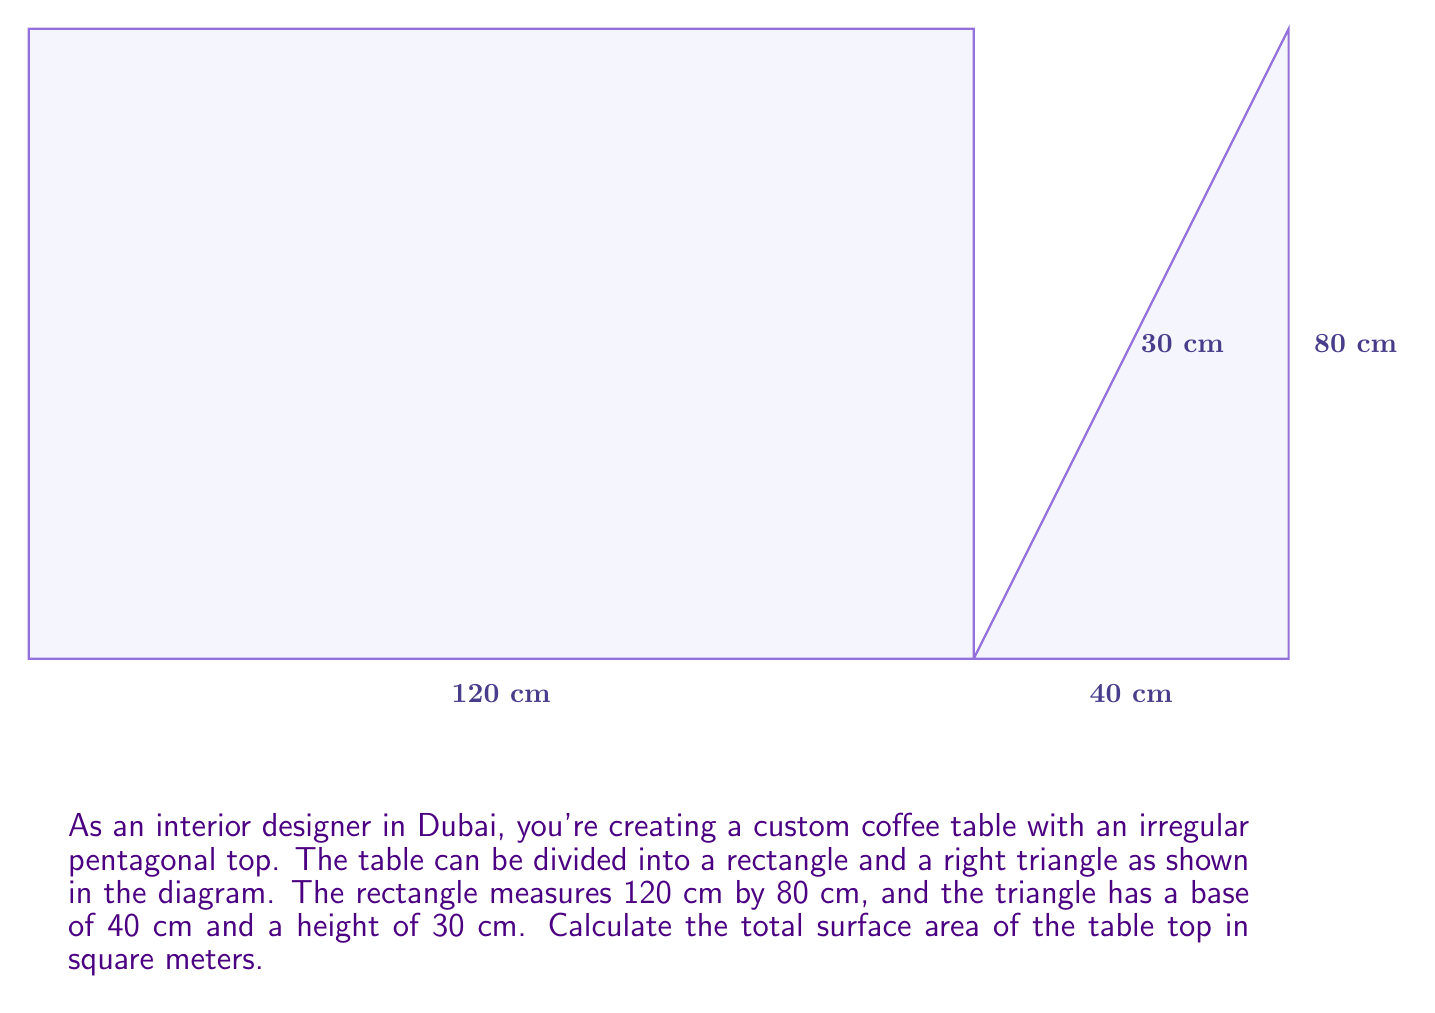Help me with this question. To solve this problem, we'll follow these steps:

1) Calculate the area of the rectangle:
   $$A_{rectangle} = length \times width = 120 \text{ cm} \times 80 \text{ cm} = 9600 \text{ cm}^2$$

2) Calculate the area of the right triangle:
   $$A_{triangle} = \frac{1}{2} \times base \times height = \frac{1}{2} \times 40 \text{ cm} \times 30 \text{ cm} = 600 \text{ cm}^2$$

3) Sum up the areas to get the total surface area:
   $$A_{total} = A_{rectangle} + A_{triangle} = 9600 \text{ cm}^2 + 600 \text{ cm}^2 = 10200 \text{ cm}^2$$

4) Convert the result from square centimeters to square meters:
   $$A_{total} = 10200 \text{ cm}^2 \times \left(\frac{1 \text{ m}}{100 \text{ cm}}\right)^2 = 1.02 \text{ m}^2$$

Therefore, the total surface area of the table top is 1.02 square meters.
Answer: $1.02 \text{ m}^2$ 